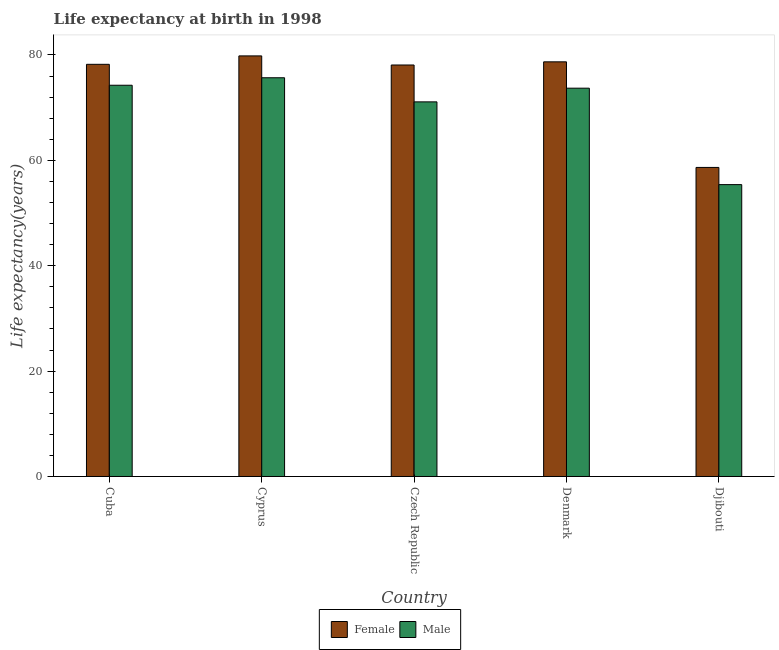What is the label of the 3rd group of bars from the left?
Give a very brief answer. Czech Republic. What is the life expectancy(male) in Cuba?
Offer a terse response. 74.26. Across all countries, what is the maximum life expectancy(male)?
Your answer should be compact. 75.68. Across all countries, what is the minimum life expectancy(female)?
Provide a succinct answer. 58.66. In which country was the life expectancy(female) maximum?
Your response must be concise. Cyprus. In which country was the life expectancy(male) minimum?
Ensure brevity in your answer.  Djibouti. What is the total life expectancy(female) in the graph?
Provide a short and direct response. 373.51. What is the difference between the life expectancy(male) in Cuba and that in Denmark?
Your answer should be very brief. 0.56. What is the difference between the life expectancy(male) in Denmark and the life expectancy(female) in Djibouti?
Keep it short and to the point. 15.04. What is the average life expectancy(male) per country?
Keep it short and to the point. 70.03. What is the difference between the life expectancy(male) and life expectancy(female) in Cyprus?
Give a very brief answer. -4.15. What is the ratio of the life expectancy(female) in Denmark to that in Djibouti?
Your answer should be compact. 1.34. Is the difference between the life expectancy(male) in Cuba and Cyprus greater than the difference between the life expectancy(female) in Cuba and Cyprus?
Your answer should be very brief. Yes. What is the difference between the highest and the second highest life expectancy(female)?
Your answer should be compact. 1.12. What is the difference between the highest and the lowest life expectancy(male)?
Give a very brief answer. 20.28. Is the sum of the life expectancy(male) in Czech Republic and Denmark greater than the maximum life expectancy(female) across all countries?
Offer a terse response. Yes. What does the 1st bar from the left in Cuba represents?
Give a very brief answer. Female. What does the 2nd bar from the right in Czech Republic represents?
Offer a very short reply. Female. How many bars are there?
Make the answer very short. 10. Are all the bars in the graph horizontal?
Offer a terse response. No. What is the difference between two consecutive major ticks on the Y-axis?
Keep it short and to the point. 20. Does the graph contain any zero values?
Your response must be concise. No. Where does the legend appear in the graph?
Ensure brevity in your answer.  Bottom center. How are the legend labels stacked?
Your response must be concise. Horizontal. What is the title of the graph?
Give a very brief answer. Life expectancy at birth in 1998. What is the label or title of the Y-axis?
Your response must be concise. Life expectancy(years). What is the Life expectancy(years) in Female in Cuba?
Your answer should be very brief. 78.23. What is the Life expectancy(years) of Male in Cuba?
Your response must be concise. 74.26. What is the Life expectancy(years) in Female in Cyprus?
Provide a short and direct response. 79.83. What is the Life expectancy(years) in Male in Cyprus?
Give a very brief answer. 75.68. What is the Life expectancy(years) of Female in Czech Republic?
Your answer should be very brief. 78.1. What is the Life expectancy(years) of Male in Czech Republic?
Keep it short and to the point. 71.1. What is the Life expectancy(years) in Female in Denmark?
Offer a terse response. 78.7. What is the Life expectancy(years) in Male in Denmark?
Your answer should be very brief. 73.7. What is the Life expectancy(years) of Female in Djibouti?
Make the answer very short. 58.66. What is the Life expectancy(years) of Male in Djibouti?
Provide a short and direct response. 55.4. Across all countries, what is the maximum Life expectancy(years) in Female?
Your answer should be very brief. 79.83. Across all countries, what is the maximum Life expectancy(years) in Male?
Make the answer very short. 75.68. Across all countries, what is the minimum Life expectancy(years) of Female?
Your answer should be compact. 58.66. Across all countries, what is the minimum Life expectancy(years) of Male?
Your answer should be very brief. 55.4. What is the total Life expectancy(years) in Female in the graph?
Ensure brevity in your answer.  373.51. What is the total Life expectancy(years) in Male in the graph?
Ensure brevity in your answer.  350.13. What is the difference between the Life expectancy(years) of Female in Cuba and that in Cyprus?
Provide a succinct answer. -1.6. What is the difference between the Life expectancy(years) of Male in Cuba and that in Cyprus?
Keep it short and to the point. -1.42. What is the difference between the Life expectancy(years) in Female in Cuba and that in Czech Republic?
Make the answer very short. 0.13. What is the difference between the Life expectancy(years) in Male in Cuba and that in Czech Republic?
Provide a short and direct response. 3.16. What is the difference between the Life expectancy(years) in Female in Cuba and that in Denmark?
Make the answer very short. -0.47. What is the difference between the Life expectancy(years) of Male in Cuba and that in Denmark?
Give a very brief answer. 0.56. What is the difference between the Life expectancy(years) of Female in Cuba and that in Djibouti?
Offer a terse response. 19.57. What is the difference between the Life expectancy(years) in Male in Cuba and that in Djibouti?
Provide a short and direct response. 18.86. What is the difference between the Life expectancy(years) in Female in Cyprus and that in Czech Republic?
Keep it short and to the point. 1.73. What is the difference between the Life expectancy(years) in Male in Cyprus and that in Czech Republic?
Your answer should be compact. 4.58. What is the difference between the Life expectancy(years) in Male in Cyprus and that in Denmark?
Your response must be concise. 1.98. What is the difference between the Life expectancy(years) of Female in Cyprus and that in Djibouti?
Provide a short and direct response. 21.17. What is the difference between the Life expectancy(years) in Male in Cyprus and that in Djibouti?
Make the answer very short. 20.28. What is the difference between the Life expectancy(years) in Male in Czech Republic and that in Denmark?
Keep it short and to the point. -2.6. What is the difference between the Life expectancy(years) in Female in Czech Republic and that in Djibouti?
Your answer should be very brief. 19.44. What is the difference between the Life expectancy(years) in Male in Czech Republic and that in Djibouti?
Make the answer very short. 15.7. What is the difference between the Life expectancy(years) of Female in Denmark and that in Djibouti?
Give a very brief answer. 20.04. What is the difference between the Life expectancy(years) in Male in Denmark and that in Djibouti?
Ensure brevity in your answer.  18.3. What is the difference between the Life expectancy(years) of Female in Cuba and the Life expectancy(years) of Male in Cyprus?
Offer a terse response. 2.55. What is the difference between the Life expectancy(years) of Female in Cuba and the Life expectancy(years) of Male in Czech Republic?
Your answer should be very brief. 7.13. What is the difference between the Life expectancy(years) in Female in Cuba and the Life expectancy(years) in Male in Denmark?
Keep it short and to the point. 4.53. What is the difference between the Life expectancy(years) in Female in Cuba and the Life expectancy(years) in Male in Djibouti?
Make the answer very short. 22.83. What is the difference between the Life expectancy(years) of Female in Cyprus and the Life expectancy(years) of Male in Czech Republic?
Give a very brief answer. 8.72. What is the difference between the Life expectancy(years) of Female in Cyprus and the Life expectancy(years) of Male in Denmark?
Keep it short and to the point. 6.12. What is the difference between the Life expectancy(years) of Female in Cyprus and the Life expectancy(years) of Male in Djibouti?
Keep it short and to the point. 24.43. What is the difference between the Life expectancy(years) of Female in Czech Republic and the Life expectancy(years) of Male in Djibouti?
Offer a very short reply. 22.7. What is the difference between the Life expectancy(years) of Female in Denmark and the Life expectancy(years) of Male in Djibouti?
Provide a succinct answer. 23.3. What is the average Life expectancy(years) in Female per country?
Your answer should be compact. 74.7. What is the average Life expectancy(years) of Male per country?
Give a very brief answer. 70.03. What is the difference between the Life expectancy(years) in Female and Life expectancy(years) in Male in Cuba?
Offer a terse response. 3.97. What is the difference between the Life expectancy(years) in Female and Life expectancy(years) in Male in Cyprus?
Offer a very short reply. 4.15. What is the difference between the Life expectancy(years) of Female and Life expectancy(years) of Male in Czech Republic?
Keep it short and to the point. 7. What is the difference between the Life expectancy(years) of Female and Life expectancy(years) of Male in Djibouti?
Offer a very short reply. 3.26. What is the ratio of the Life expectancy(years) of Female in Cuba to that in Cyprus?
Provide a succinct answer. 0.98. What is the ratio of the Life expectancy(years) in Male in Cuba to that in Cyprus?
Your answer should be very brief. 0.98. What is the ratio of the Life expectancy(years) of Female in Cuba to that in Czech Republic?
Offer a terse response. 1. What is the ratio of the Life expectancy(years) in Male in Cuba to that in Czech Republic?
Your answer should be compact. 1.04. What is the ratio of the Life expectancy(years) in Female in Cuba to that in Denmark?
Provide a succinct answer. 0.99. What is the ratio of the Life expectancy(years) of Male in Cuba to that in Denmark?
Keep it short and to the point. 1.01. What is the ratio of the Life expectancy(years) of Female in Cuba to that in Djibouti?
Your answer should be compact. 1.33. What is the ratio of the Life expectancy(years) of Male in Cuba to that in Djibouti?
Ensure brevity in your answer.  1.34. What is the ratio of the Life expectancy(years) in Female in Cyprus to that in Czech Republic?
Make the answer very short. 1.02. What is the ratio of the Life expectancy(years) in Male in Cyprus to that in Czech Republic?
Provide a short and direct response. 1.06. What is the ratio of the Life expectancy(years) of Female in Cyprus to that in Denmark?
Offer a very short reply. 1.01. What is the ratio of the Life expectancy(years) of Male in Cyprus to that in Denmark?
Make the answer very short. 1.03. What is the ratio of the Life expectancy(years) in Female in Cyprus to that in Djibouti?
Ensure brevity in your answer.  1.36. What is the ratio of the Life expectancy(years) of Male in Cyprus to that in Djibouti?
Keep it short and to the point. 1.37. What is the ratio of the Life expectancy(years) of Female in Czech Republic to that in Denmark?
Offer a terse response. 0.99. What is the ratio of the Life expectancy(years) in Male in Czech Republic to that in Denmark?
Your response must be concise. 0.96. What is the ratio of the Life expectancy(years) in Female in Czech Republic to that in Djibouti?
Offer a very short reply. 1.33. What is the ratio of the Life expectancy(years) in Male in Czech Republic to that in Djibouti?
Offer a very short reply. 1.28. What is the ratio of the Life expectancy(years) in Female in Denmark to that in Djibouti?
Give a very brief answer. 1.34. What is the ratio of the Life expectancy(years) in Male in Denmark to that in Djibouti?
Ensure brevity in your answer.  1.33. What is the difference between the highest and the second highest Life expectancy(years) in Male?
Provide a succinct answer. 1.42. What is the difference between the highest and the lowest Life expectancy(years) of Female?
Make the answer very short. 21.17. What is the difference between the highest and the lowest Life expectancy(years) in Male?
Your response must be concise. 20.28. 